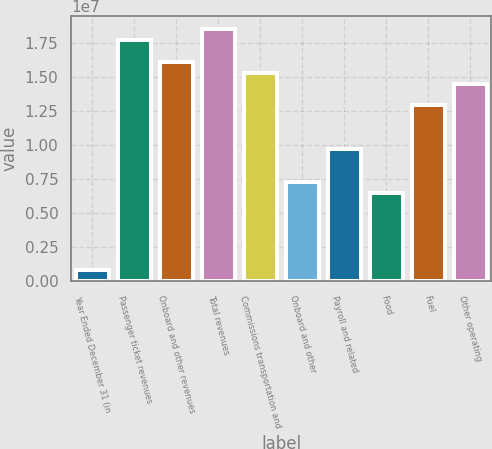<chart> <loc_0><loc_0><loc_500><loc_500><bar_chart><fcel>Year Ended December 31 (in<fcel>Passenger ticket revenues<fcel>Onboard and other revenues<fcel>Total revenues<fcel>Commissions transportation and<fcel>Onboard and other<fcel>Payroll and related<fcel>Food<fcel>Fuel<fcel>Other operating<nl><fcel>807389<fcel>1.77625e+07<fcel>1.61477e+07<fcel>1.85699e+07<fcel>1.53403e+07<fcel>7.26647e+06<fcel>9.68863e+06<fcel>6.45908e+06<fcel>1.29182e+07<fcel>1.45329e+07<nl></chart> 